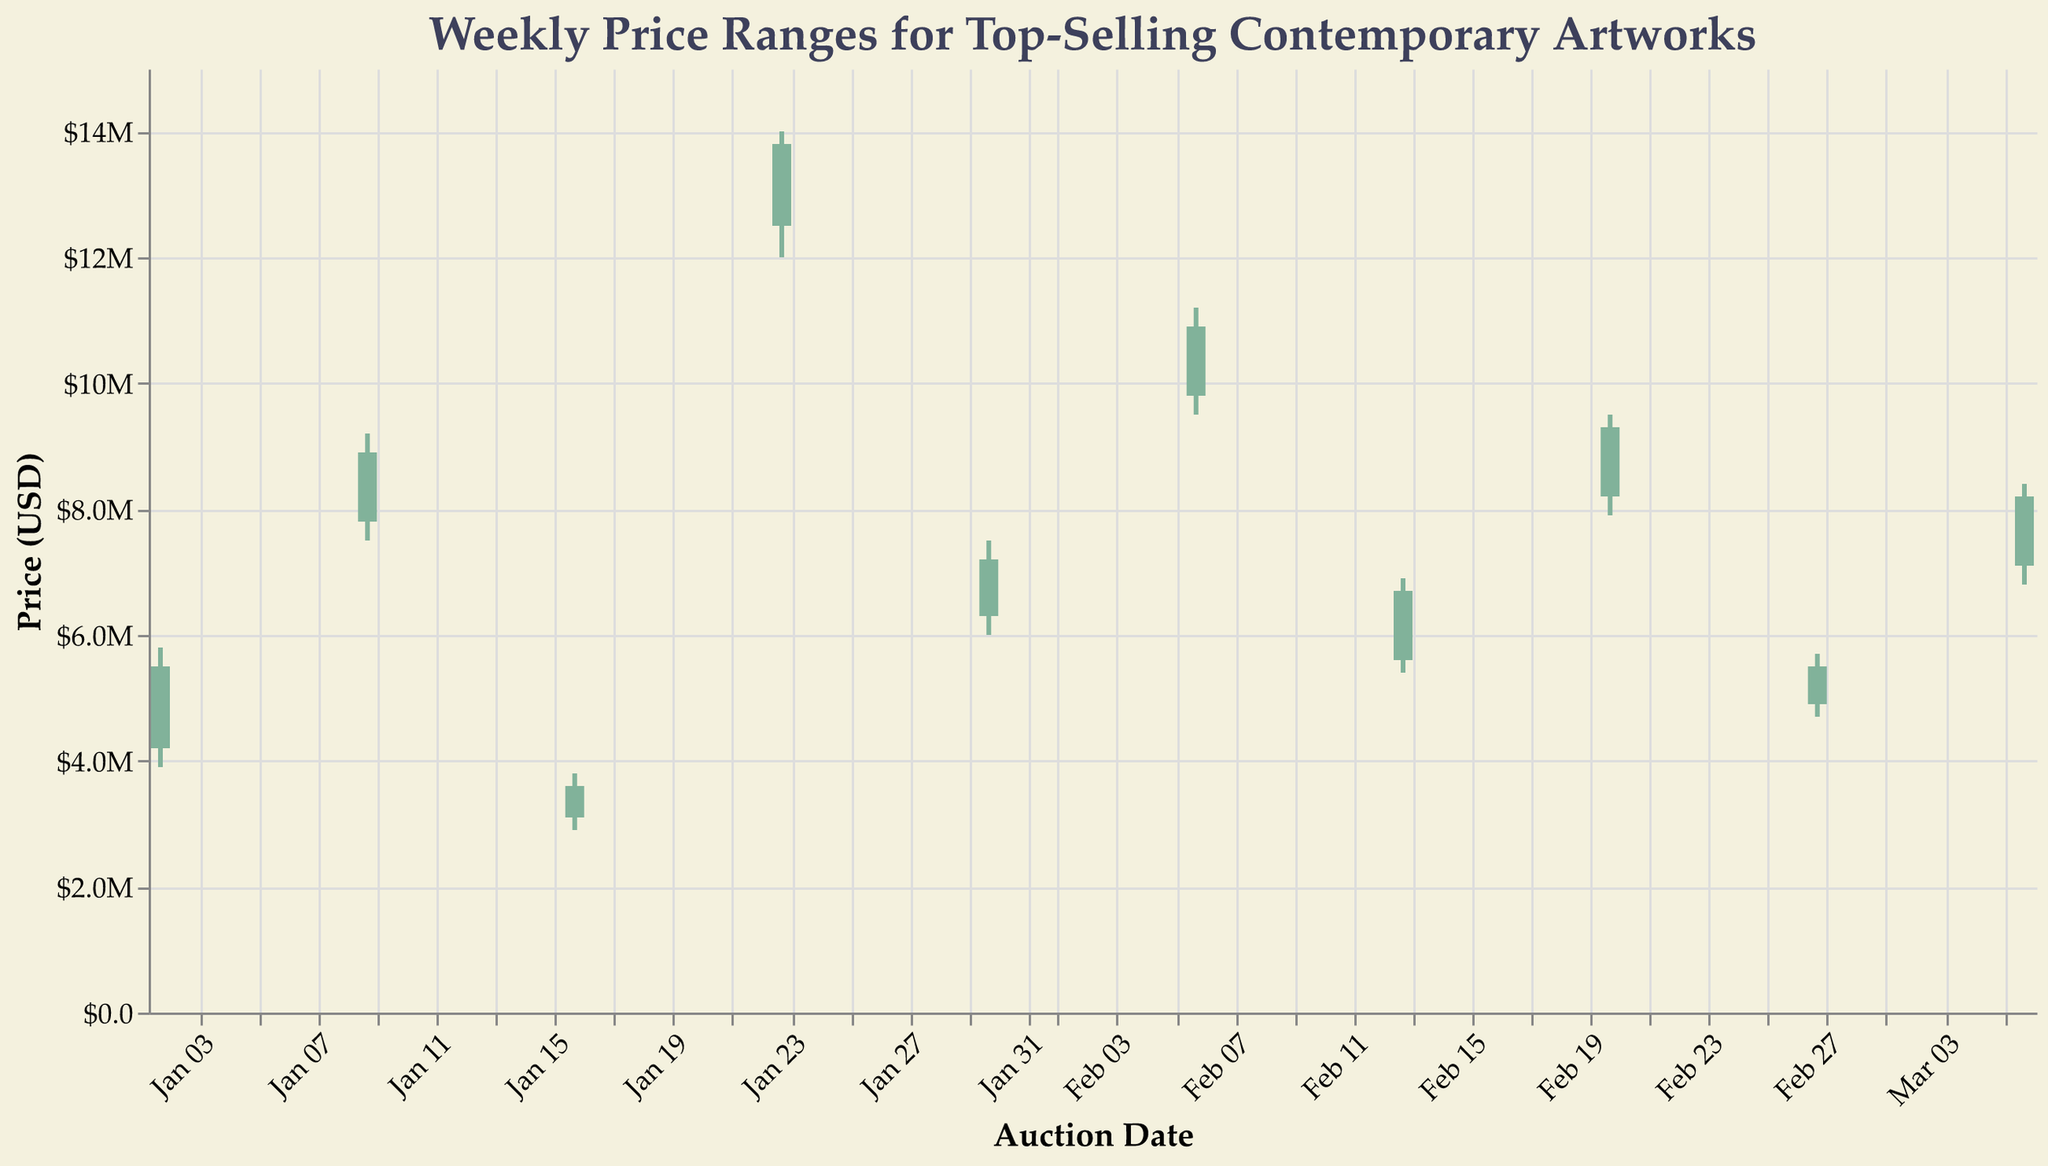what is the title of the figure? The title is displayed at the top of the figure. It reads "Weekly Price Ranges for Top-Selling Contemporary Artworks."
Answer: Weekly Price Ranges for Top-Selling Contemporary Artworks which week's data shows the highest closing price? The highest closing price can be identified by looking at the highest 'Close' value. David Hockney's "Portrait of an Artist" on January 23, 2023, has the highest closing price of $13,800,000.
Answer: January 23, 2023 what is the price range (difference between high and low) for Yayoi Kusama's "Infinity Net"? To calculate the price range, subtract the 'Low' price from the 'High' price. For Yayoi Kusama's "Infinity Net", the 'High' is $9,200,000 and the 'Low' is $7,500,000. The price range is $9,200,000 - $7,500,000 = $1,700,000.
Answer: $1,700,000 which artist's artwork had the smallest price range, and what was the range? To find the smallest price range, calculate the difference between 'High' and 'Low' prices for each artwork and identify the smallest one. Banksy's "Love is in the Bin" had the smallest price range: $3,800,000 - $2,900,000 = $900,000.
Answer: Banksy, $900,000 what is the average closing price of the artworks sold in February 2023? To find the average closing price of February 2023 artworks, sum the 'Close' prices and divide by the number of artworks in February:
* February 6: $10,900,000
* February 13: $6,700,000
* February 20: $9,300,000
* February 27: $5,500,000
Sum: $10,900,000 + $6,700,000 + $9,300,000 + $5,500,000 = $32,400,000
Average: $32,400,000 / 4 = $8,100,000.
Answer: $8,100,000 which artwork experienced the greatest increase in price from open to close? The greatest increase in price from 'Open' to 'Close' can be found by subtracting 'Open' from 'Close' and identifying the largest positive difference. David Hockney's "Portrait of an Artist" had the greatest increase: $13,800,000 - $12,500,000 = $1,300,000.
Answer: David Hockney, $1,300,000 how many artworks had a closing price higher than their opening price? To determine this, count the number of instances where the 'Close' price is greater than the 'Open' price. There are 5 such artworks in the dataset: "Untitled (Skull)", "Infinity Net", "Portrait of an Artist", "Balloon Dog (Orange)", and "Untitled (Riot)".
Answer: 5 what is the median 'High' price of the artworks displayed in the chart? To find the median, list all 'High' prices in ascending order and identify the middle number. The 'High' prices are:
* $3,800,000, $5,700,000, $5,800,000, $6,900,000, $7,500,000, $8,400,000, $9,200,000, $9,500,000, $11,200,000, $14,000,000
Being 10 numbers, the median is the average of the 5th and 6th values:
($7,500,000 + $8,400,000) / 2 = $7,950,000.
Answer: $7,950,000 